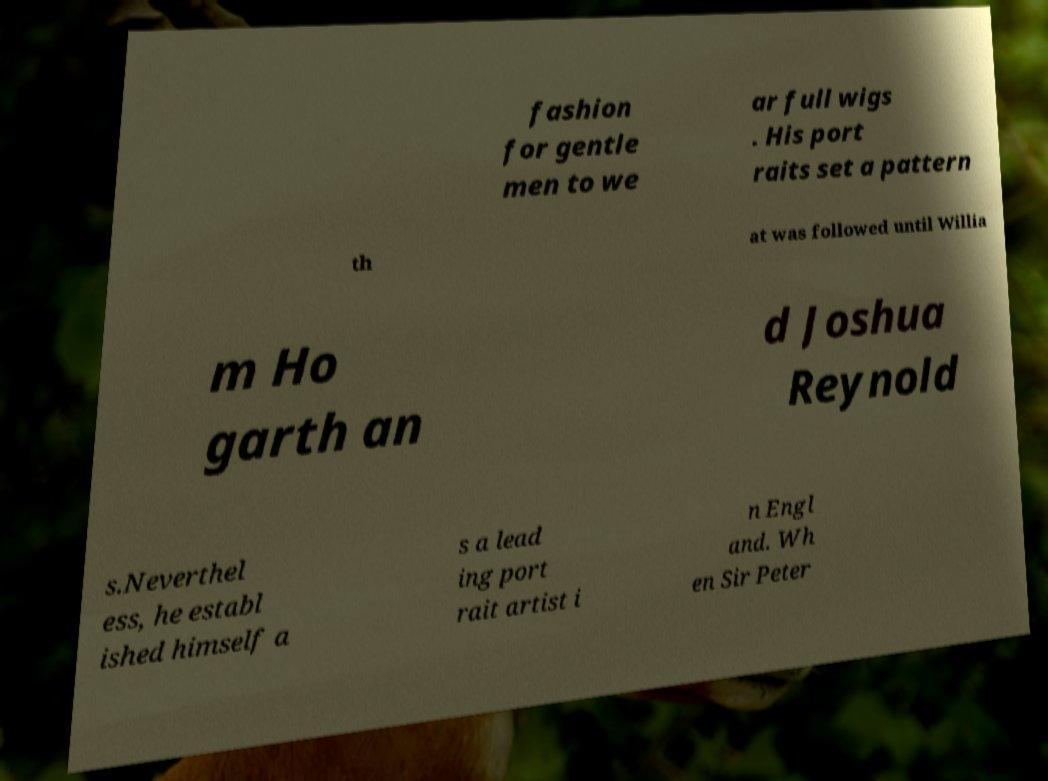Could you assist in decoding the text presented in this image and type it out clearly? fashion for gentle men to we ar full wigs . His port raits set a pattern th at was followed until Willia m Ho garth an d Joshua Reynold s.Neverthel ess, he establ ished himself a s a lead ing port rait artist i n Engl and. Wh en Sir Peter 